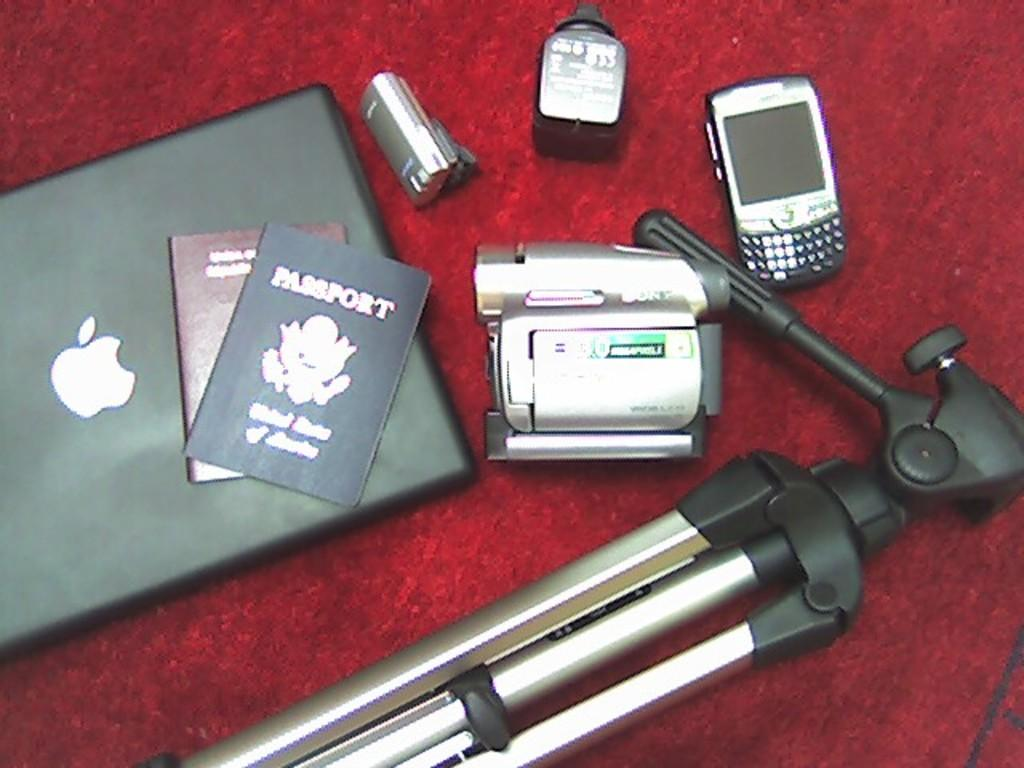<image>
Present a compact description of the photo's key features. A United States of America Passport sits on top of an Apple computer 